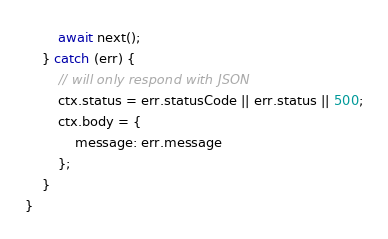Convert code to text. <code><loc_0><loc_0><loc_500><loc_500><_JavaScript_>        await next();
    } catch (err) {
        // will only respond with JSON
        ctx.status = err.statusCode || err.status || 500;
        ctx.body = {
            message: err.message
        };
    }
}
</code> 